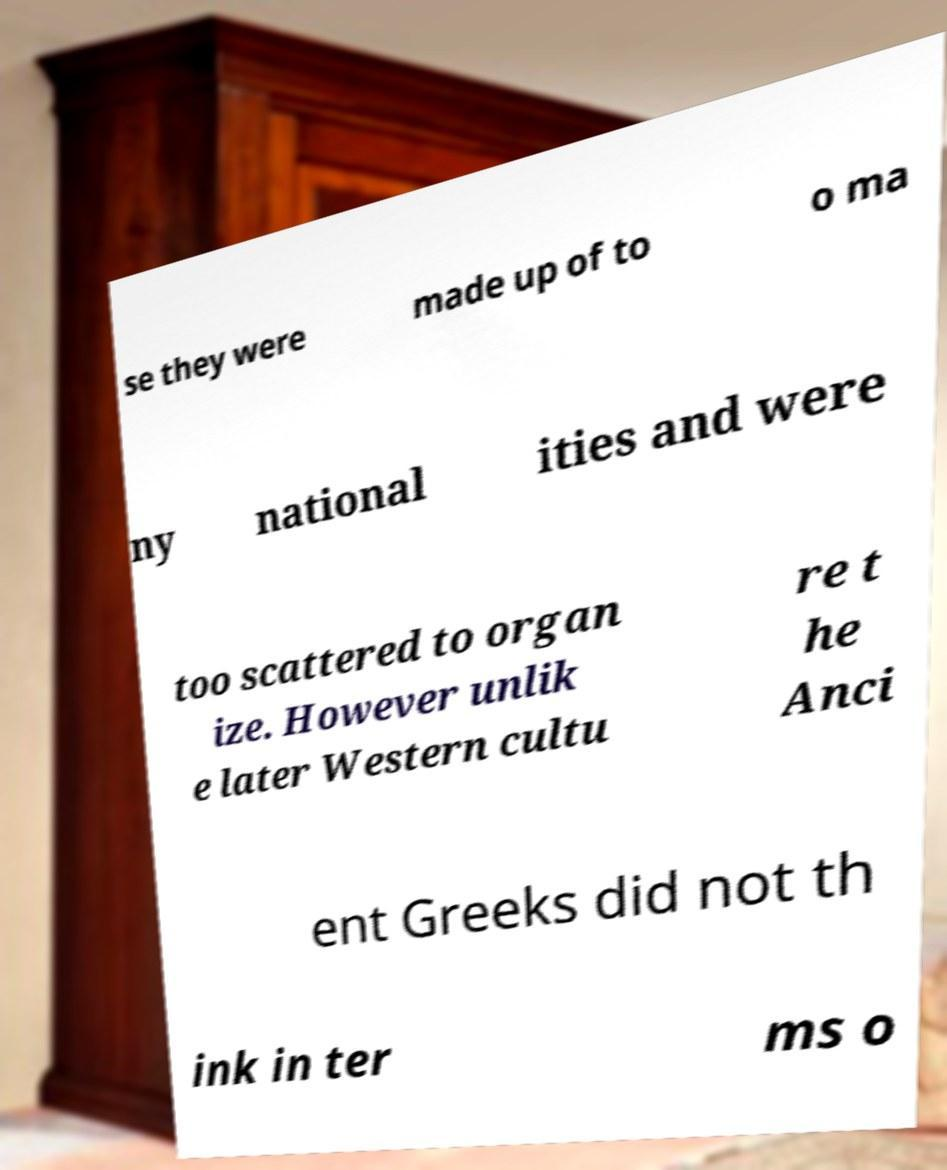Could you assist in decoding the text presented in this image and type it out clearly? se they were made up of to o ma ny national ities and were too scattered to organ ize. However unlik e later Western cultu re t he Anci ent Greeks did not th ink in ter ms o 